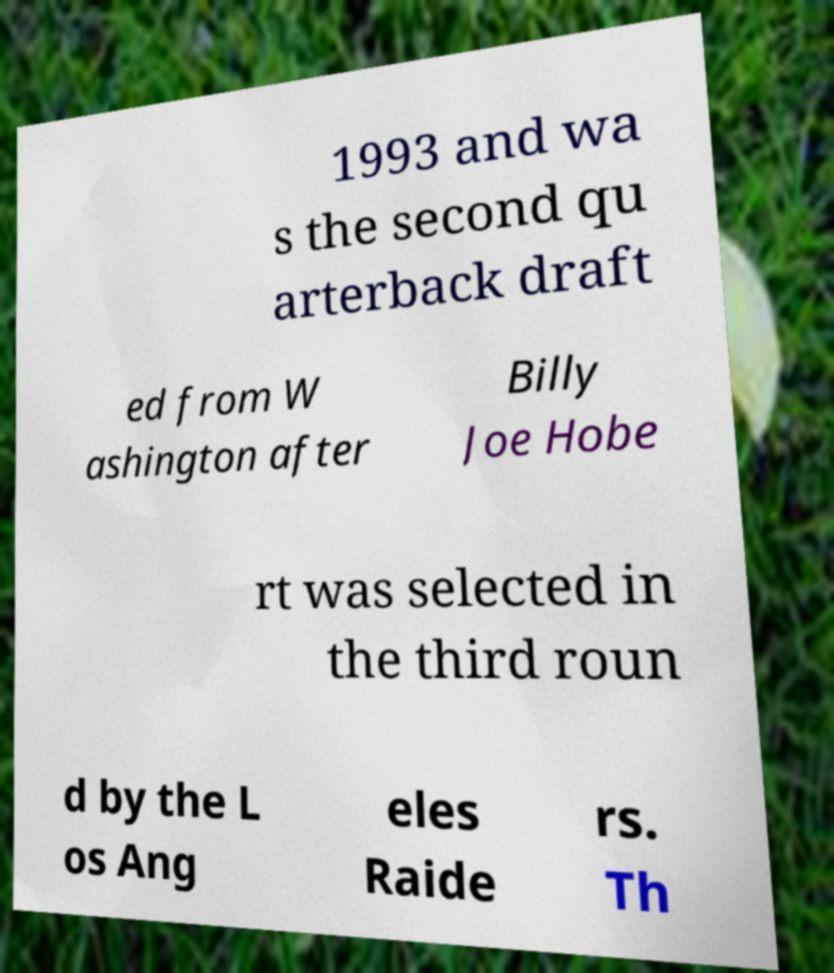Could you extract and type out the text from this image? 1993 and wa s the second qu arterback draft ed from W ashington after Billy Joe Hobe rt was selected in the third roun d by the L os Ang eles Raide rs. Th 